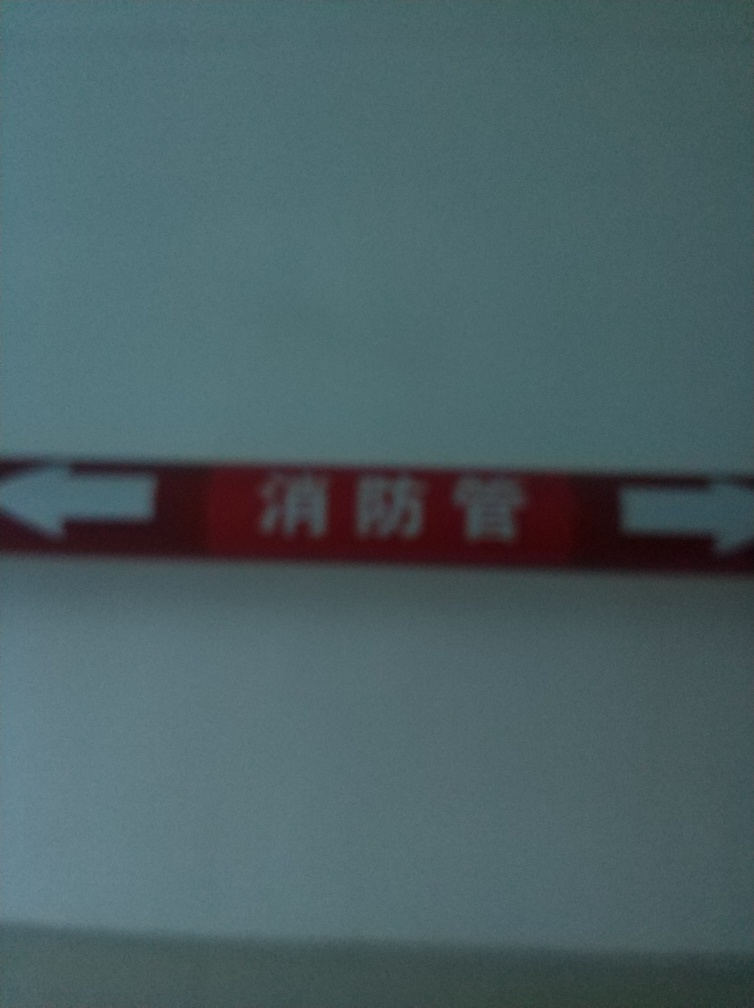How could the quality of this image be improved? To enhance the quality of the image, several steps could be taken: ensuring the camera's focus is sharp; using a higher resolution camera or settings; stabilizing the camera to avoid blur from movement; and employing optimal lighting to reduce shadows and glare, which can obscure details. If I wanted to interpret this sign, what could be some general suggestions? To interpret a blurry sign like this, you might increase the image's contrast or sharpness using photo editing tools, attempt to revisit the location to take a clearer photo, or consult someone who might recognize the sign's context and provide probable interpretations based on partial visual cues. 